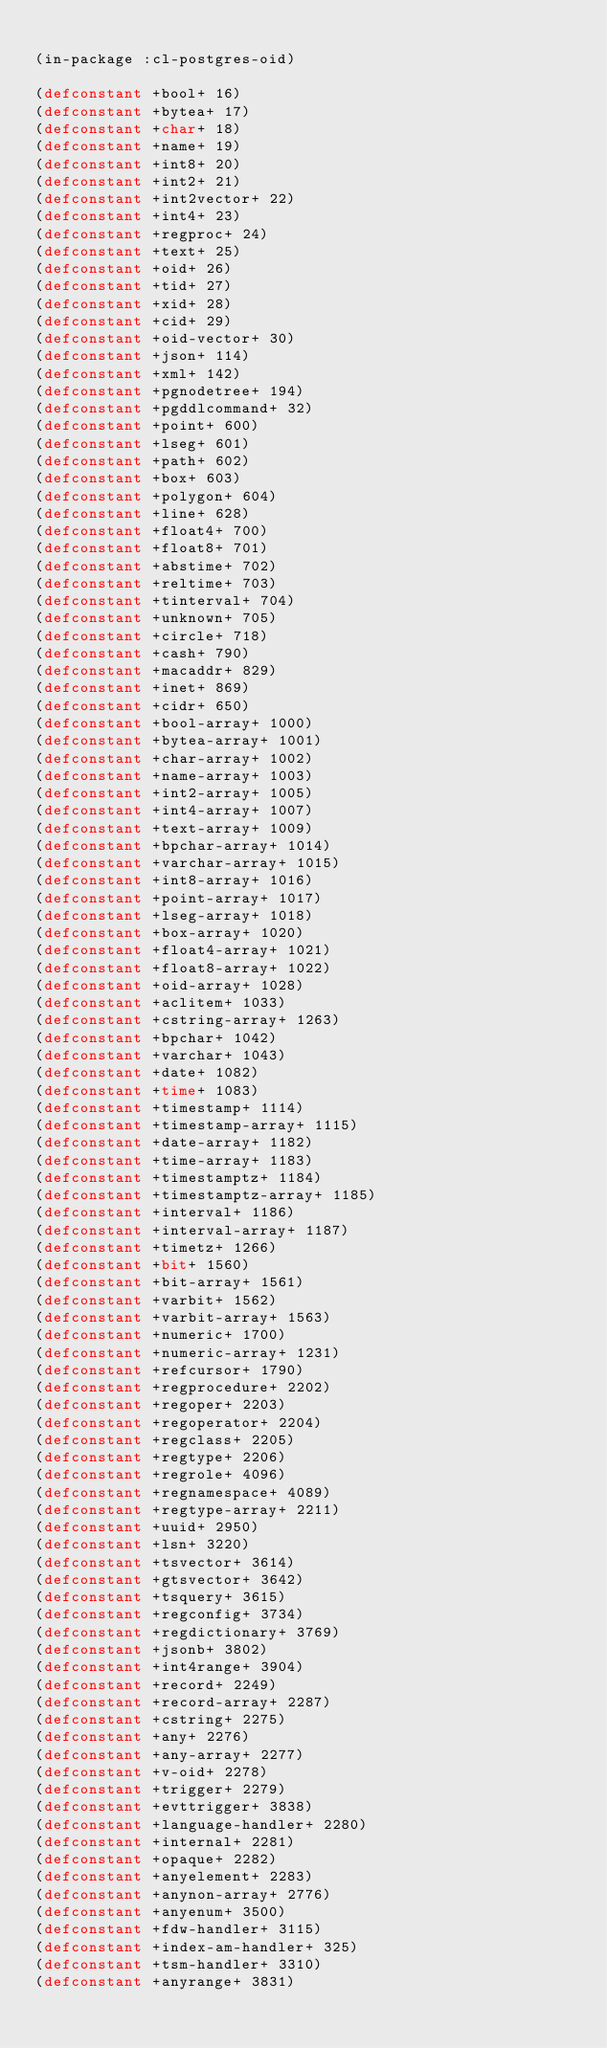Convert code to text. <code><loc_0><loc_0><loc_500><loc_500><_Lisp_>
(in-package :cl-postgres-oid)

(defconstant +bool+ 16)
(defconstant +bytea+ 17)
(defconstant +char+ 18)
(defconstant +name+ 19)
(defconstant +int8+ 20)
(defconstant +int2+ 21)
(defconstant +int2vector+ 22)
(defconstant +int4+ 23)
(defconstant +regproc+ 24)
(defconstant +text+ 25)
(defconstant +oid+ 26)
(defconstant +tid+ 27)
(defconstant +xid+ 28)
(defconstant +cid+ 29)
(defconstant +oid-vector+ 30)
(defconstant +json+ 114)
(defconstant +xml+ 142)
(defconstant +pgnodetree+ 194)
(defconstant +pgddlcommand+ 32)
(defconstant +point+ 600)
(defconstant +lseg+ 601)
(defconstant +path+ 602)
(defconstant +box+ 603)
(defconstant +polygon+ 604)
(defconstant +line+ 628)
(defconstant +float4+ 700)
(defconstant +float8+ 701)
(defconstant +abstime+ 702)
(defconstant +reltime+ 703)
(defconstant +tinterval+ 704)
(defconstant +unknown+ 705)
(defconstant +circle+ 718)
(defconstant +cash+ 790)
(defconstant +macaddr+ 829)
(defconstant +inet+ 869)
(defconstant +cidr+ 650)
(defconstant +bool-array+ 1000)
(defconstant +bytea-array+ 1001)
(defconstant +char-array+ 1002)
(defconstant +name-array+ 1003)
(defconstant +int2-array+ 1005)
(defconstant +int4-array+ 1007)
(defconstant +text-array+ 1009)
(defconstant +bpchar-array+ 1014)
(defconstant +varchar-array+ 1015)
(defconstant +int8-array+ 1016)
(defconstant +point-array+ 1017)
(defconstant +lseg-array+ 1018)
(defconstant +box-array+ 1020)
(defconstant +float4-array+ 1021)
(defconstant +float8-array+ 1022)
(defconstant +oid-array+ 1028)
(defconstant +aclitem+ 1033)
(defconstant +cstring-array+ 1263)
(defconstant +bpchar+ 1042)
(defconstant +varchar+ 1043)
(defconstant +date+ 1082)
(defconstant +time+ 1083)
(defconstant +timestamp+ 1114)
(defconstant +timestamp-array+ 1115)
(defconstant +date-array+ 1182)
(defconstant +time-array+ 1183)
(defconstant +timestamptz+ 1184)
(defconstant +timestamptz-array+ 1185)
(defconstant +interval+ 1186)
(defconstant +interval-array+ 1187)
(defconstant +timetz+ 1266)
(defconstant +bit+ 1560)
(defconstant +bit-array+ 1561)
(defconstant +varbit+ 1562)
(defconstant +varbit-array+ 1563)
(defconstant +numeric+ 1700)
(defconstant +numeric-array+ 1231)
(defconstant +refcursor+ 1790)
(defconstant +regprocedure+ 2202)
(defconstant +regoper+ 2203)
(defconstant +regoperator+ 2204)
(defconstant +regclass+ 2205)
(defconstant +regtype+ 2206)
(defconstant +regrole+ 4096)
(defconstant +regnamespace+ 4089)
(defconstant +regtype-array+ 2211)
(defconstant +uuid+ 2950)
(defconstant +lsn+ 3220)
(defconstant +tsvector+ 3614)
(defconstant +gtsvector+ 3642)
(defconstant +tsquery+ 3615)
(defconstant +regconfig+ 3734)
(defconstant +regdictionary+ 3769)
(defconstant +jsonb+ 3802)
(defconstant +int4range+ 3904)
(defconstant +record+ 2249)
(defconstant +record-array+ 2287)
(defconstant +cstring+ 2275)
(defconstant +any+ 2276)
(defconstant +any-array+ 2277)
(defconstant +v-oid+ 2278)
(defconstant +trigger+ 2279)
(defconstant +evttrigger+ 3838)
(defconstant +language-handler+ 2280)
(defconstant +internal+ 2281)
(defconstant +opaque+ 2282)
(defconstant +anyelement+ 2283)
(defconstant +anynon-array+ 2776)
(defconstant +anyenum+ 3500)
(defconstant +fdw-handler+ 3115)
(defconstant +index-am-handler+ 325)
(defconstant +tsm-handler+ 3310)
(defconstant +anyrange+ 3831)
</code> 